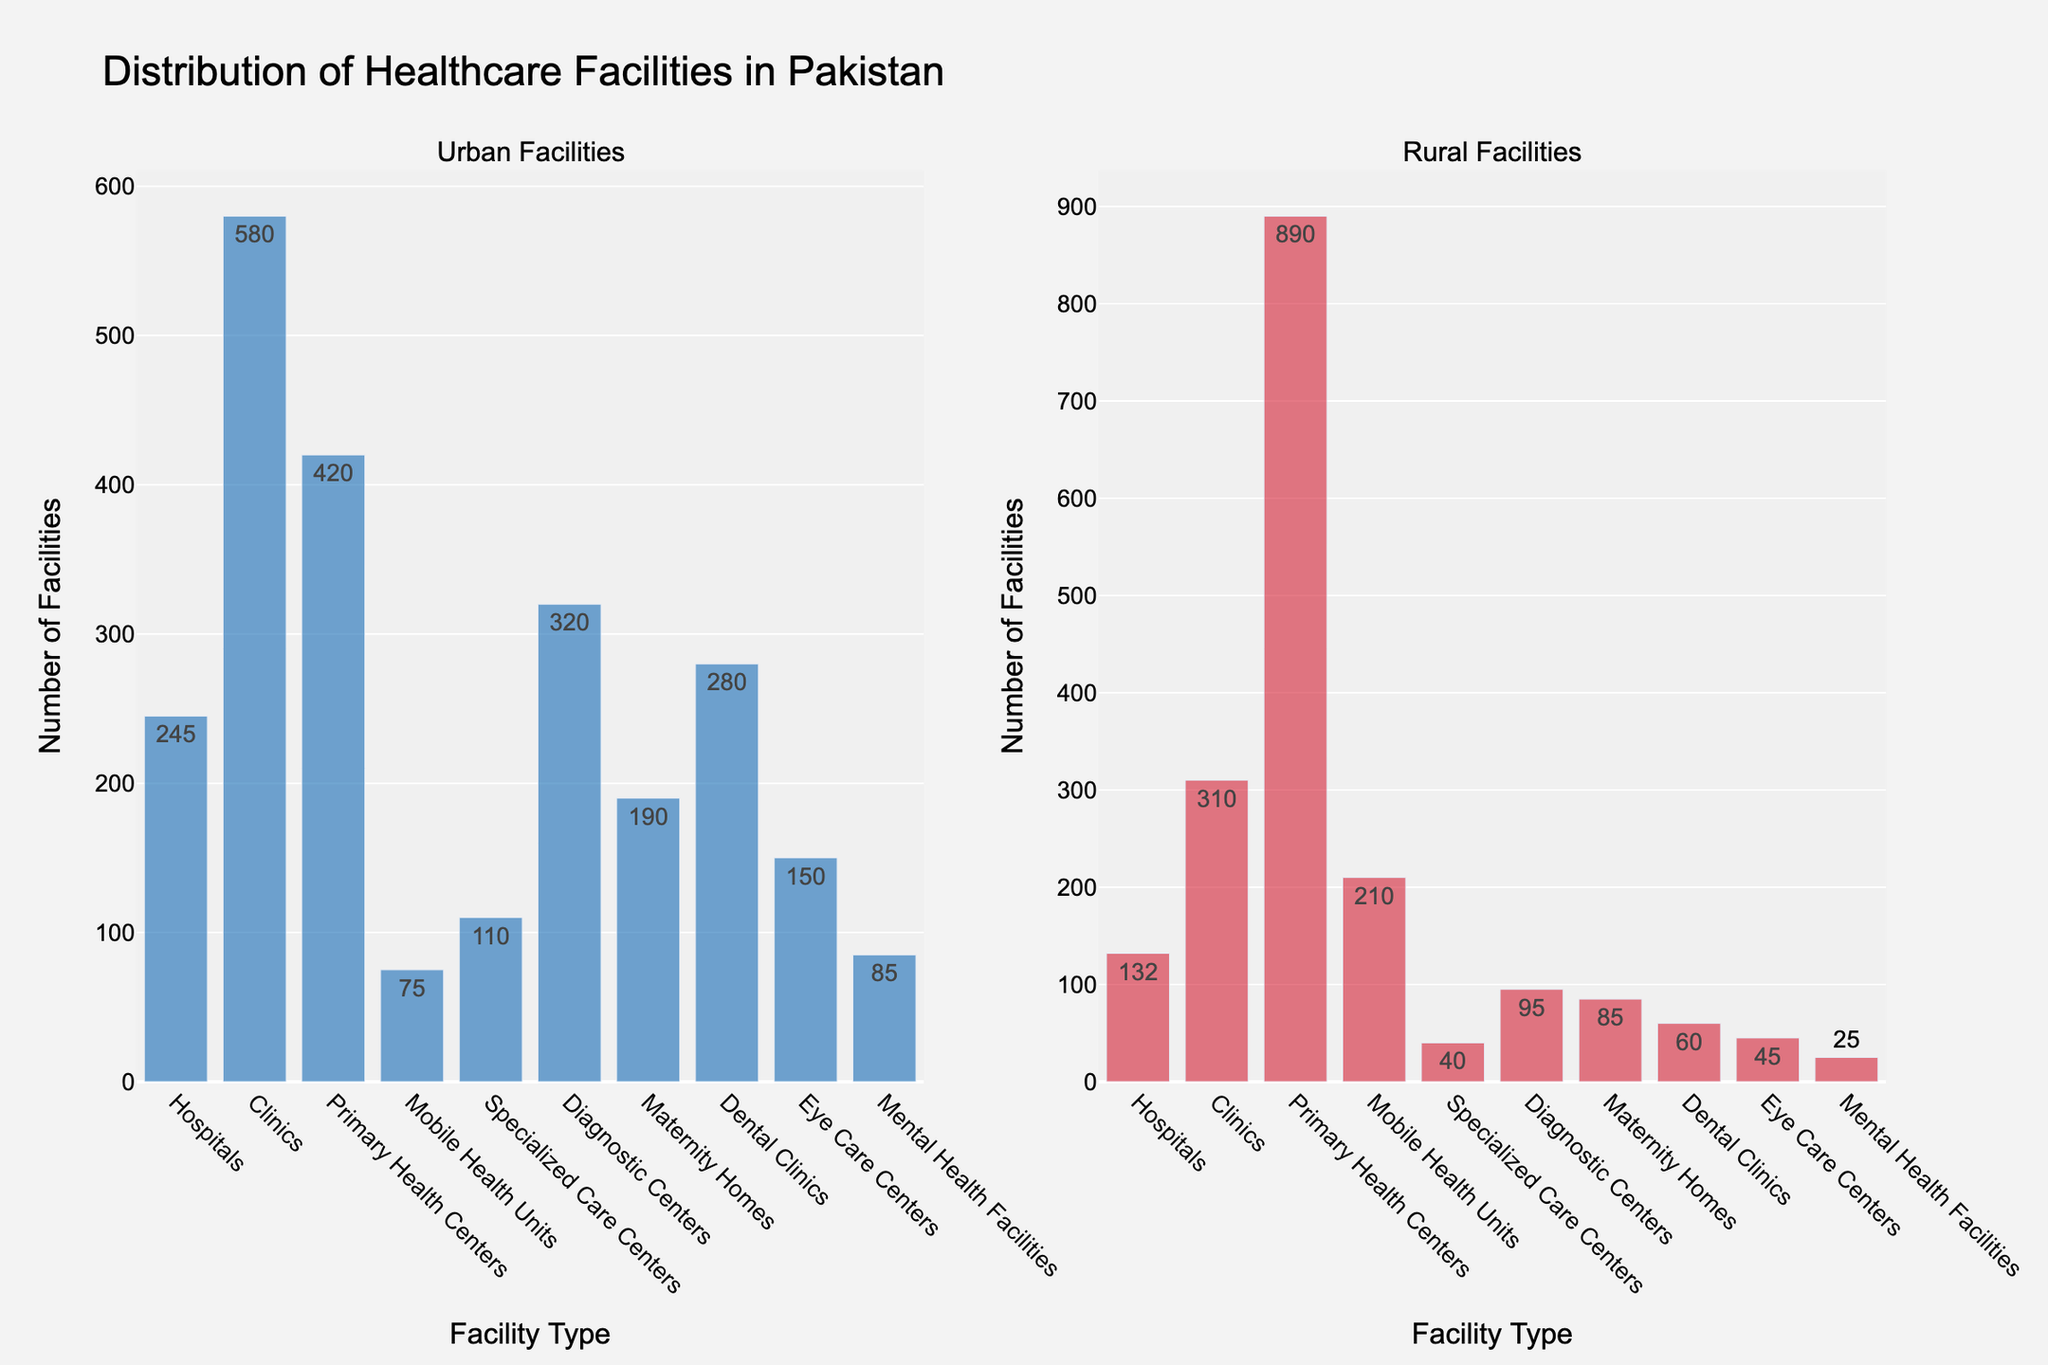What's the total number of healthcare facilities in urban areas? To find the total number of healthcare facilities in urban areas, sum up the numbers for all types of facilities listed under the 'Urban' category. The sum is 245 (Hospitals) + 580 (Clinics) + 420 (Primary Health Centers) + 75 (Mobile Health Units) + 110 (Specialized Care Centers) + 320 (Diagnostic Centers) + 190 (Maternity Homes) + 280 (Dental Clinics) + 150 (Eye Care Centers) + 85 (Mental Health Facilities) = 2455.
Answer: 2455 Which type of facility has the highest number in rural areas? By looking at the height of the bars in the 'Rural Facilities' subplot and the numeric labels, we can see that Primary Health Centers have the highest number with 890 facilities.
Answer: Primary Health Centers How many more dental clinics are there in urban areas compared to rural areas? To find out how many more dental clinics there are in urban areas compared to rural areas, subtract the number of dental clinics in rural areas (60) from the number in urban areas (280). The difference is 280 - 60 = 220.
Answer: 220 What's the average number of specialized care centers across both urban and rural areas? To find the average number of specialized care centers across both urban and rural areas, sum up the numbers for both areas and then divide by 2. The sum is 110 (Urban) + 40 (Rural) = 150. The average is 150 / 2 = 75.
Answer: 75 Which type of facility is least common in urban areas, and how many of them are there? By inspecting the 'Urban Facilities' subplot, we can see that Mobile Health Units have the shortest bar and thus the lowest count. It is labeled as having 75 facilities.
Answer: Mobile Health Units, 75 How does the number of eye care centers in rural areas compare to diagnostic centers in the same area? By comparing the heights of the bars and the numeric labels in the 'Rural Facilities' subplot, we see that Eye Care Centers have 45 facilities, while Diagnostic Centers have 95 facilities. Therefore, Diagnostic Centers have more facilities (95 compared to 45).
Answer: Eye Care Centers have fewer than Diagnostic Centers What's the combined total of maternity homes and mental health facilities in urban areas? Sum the numbers for Maternity Homes and Mental Health Facilities in urban areas. The sum is 190 (Maternity Homes) + 85 (Mental Health Facilities) = 275.
Answer: 275 Which type of facility has a higher number in rural areas compared to urban areas? By visually inspecting and comparing the heights of the bars in both subplots, we see that only Primary Health Centers and Mobile Health Units have a higher number in rural areas (890 and 210, respectively) compared to urban areas (420 and 75, respectively).
Answer: Primary Health Centers and Mobile Health Units 